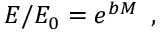Convert formula to latex. <formula><loc_0><loc_0><loc_500><loc_500>E / E _ { 0 } = e ^ { b M } \, ,</formula> 